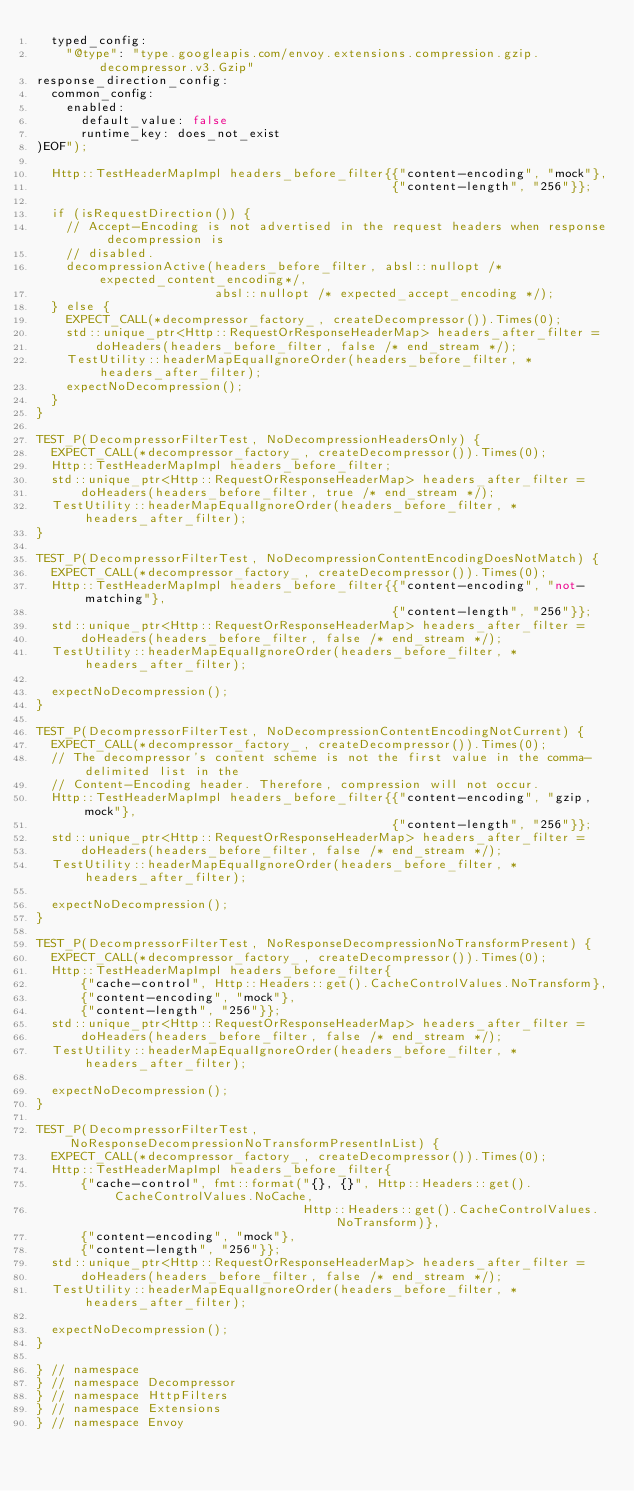Convert code to text. <code><loc_0><loc_0><loc_500><loc_500><_C++_>  typed_config:
    "@type": "type.googleapis.com/envoy.extensions.compression.gzip.decompressor.v3.Gzip"
response_direction_config:
  common_config:
    enabled:
      default_value: false
      runtime_key: does_not_exist
)EOF");

  Http::TestHeaderMapImpl headers_before_filter{{"content-encoding", "mock"},
                                                {"content-length", "256"}};

  if (isRequestDirection()) {
    // Accept-Encoding is not advertised in the request headers when response decompression is
    // disabled.
    decompressionActive(headers_before_filter, absl::nullopt /* expected_content_encoding*/,
                        absl::nullopt /* expected_accept_encoding */);
  } else {
    EXPECT_CALL(*decompressor_factory_, createDecompressor()).Times(0);
    std::unique_ptr<Http::RequestOrResponseHeaderMap> headers_after_filter =
        doHeaders(headers_before_filter, false /* end_stream */);
    TestUtility::headerMapEqualIgnoreOrder(headers_before_filter, *headers_after_filter);
    expectNoDecompression();
  }
}

TEST_P(DecompressorFilterTest, NoDecompressionHeadersOnly) {
  EXPECT_CALL(*decompressor_factory_, createDecompressor()).Times(0);
  Http::TestHeaderMapImpl headers_before_filter;
  std::unique_ptr<Http::RequestOrResponseHeaderMap> headers_after_filter =
      doHeaders(headers_before_filter, true /* end_stream */);
  TestUtility::headerMapEqualIgnoreOrder(headers_before_filter, *headers_after_filter);
}

TEST_P(DecompressorFilterTest, NoDecompressionContentEncodingDoesNotMatch) {
  EXPECT_CALL(*decompressor_factory_, createDecompressor()).Times(0);
  Http::TestHeaderMapImpl headers_before_filter{{"content-encoding", "not-matching"},
                                                {"content-length", "256"}};
  std::unique_ptr<Http::RequestOrResponseHeaderMap> headers_after_filter =
      doHeaders(headers_before_filter, false /* end_stream */);
  TestUtility::headerMapEqualIgnoreOrder(headers_before_filter, *headers_after_filter);

  expectNoDecompression();
}

TEST_P(DecompressorFilterTest, NoDecompressionContentEncodingNotCurrent) {
  EXPECT_CALL(*decompressor_factory_, createDecompressor()).Times(0);
  // The decompressor's content scheme is not the first value in the comma-delimited list in the
  // Content-Encoding header. Therefore, compression will not occur.
  Http::TestHeaderMapImpl headers_before_filter{{"content-encoding", "gzip,mock"},
                                                {"content-length", "256"}};
  std::unique_ptr<Http::RequestOrResponseHeaderMap> headers_after_filter =
      doHeaders(headers_before_filter, false /* end_stream */);
  TestUtility::headerMapEqualIgnoreOrder(headers_before_filter, *headers_after_filter);

  expectNoDecompression();
}

TEST_P(DecompressorFilterTest, NoResponseDecompressionNoTransformPresent) {
  EXPECT_CALL(*decompressor_factory_, createDecompressor()).Times(0);
  Http::TestHeaderMapImpl headers_before_filter{
      {"cache-control", Http::Headers::get().CacheControlValues.NoTransform},
      {"content-encoding", "mock"},
      {"content-length", "256"}};
  std::unique_ptr<Http::RequestOrResponseHeaderMap> headers_after_filter =
      doHeaders(headers_before_filter, false /* end_stream */);
  TestUtility::headerMapEqualIgnoreOrder(headers_before_filter, *headers_after_filter);

  expectNoDecompression();
}

TEST_P(DecompressorFilterTest, NoResponseDecompressionNoTransformPresentInList) {
  EXPECT_CALL(*decompressor_factory_, createDecompressor()).Times(0);
  Http::TestHeaderMapImpl headers_before_filter{
      {"cache-control", fmt::format("{}, {}", Http::Headers::get().CacheControlValues.NoCache,
                                    Http::Headers::get().CacheControlValues.NoTransform)},
      {"content-encoding", "mock"},
      {"content-length", "256"}};
  std::unique_ptr<Http::RequestOrResponseHeaderMap> headers_after_filter =
      doHeaders(headers_before_filter, false /* end_stream */);
  TestUtility::headerMapEqualIgnoreOrder(headers_before_filter, *headers_after_filter);

  expectNoDecompression();
}

} // namespace
} // namespace Decompressor
} // namespace HttpFilters
} // namespace Extensions
} // namespace Envoy
</code> 